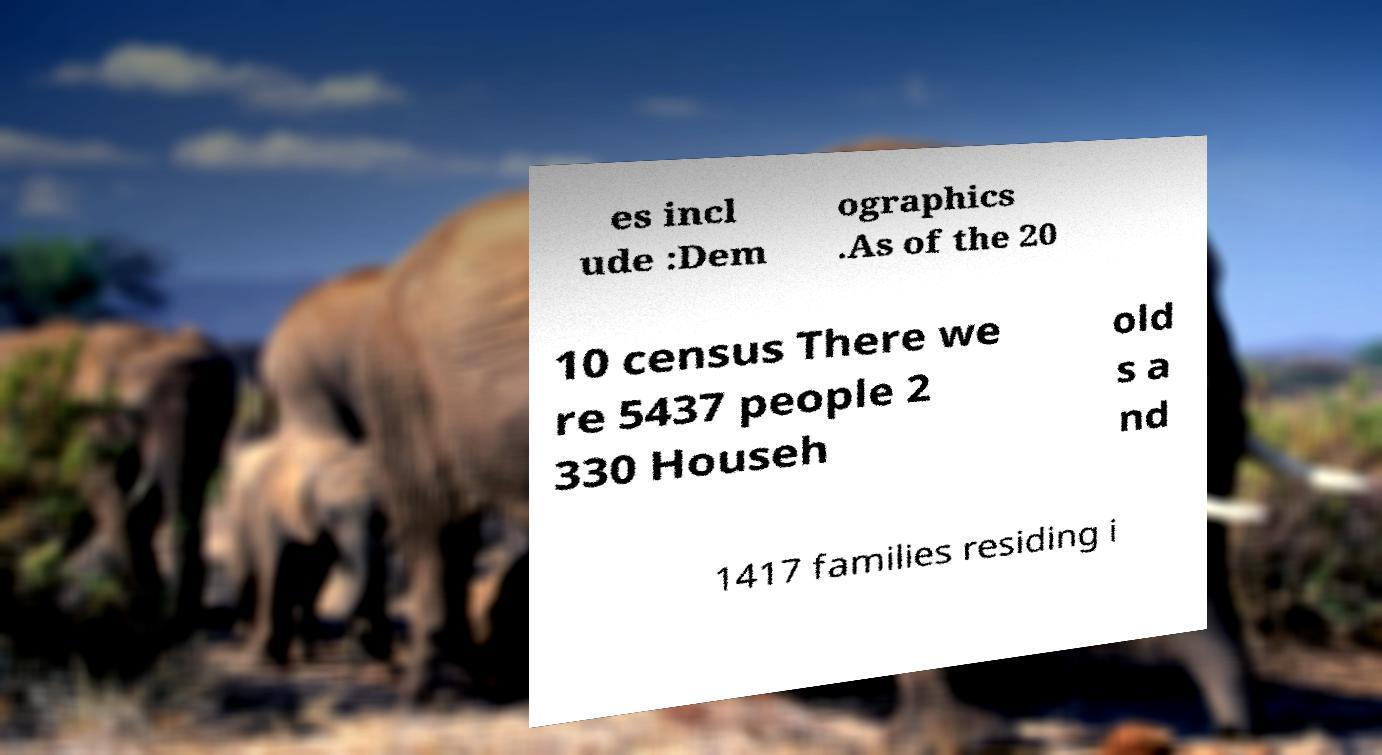Could you extract and type out the text from this image? es incl ude :Dem ographics .As of the 20 10 census There we re 5437 people 2 330 Househ old s a nd 1417 families residing i 